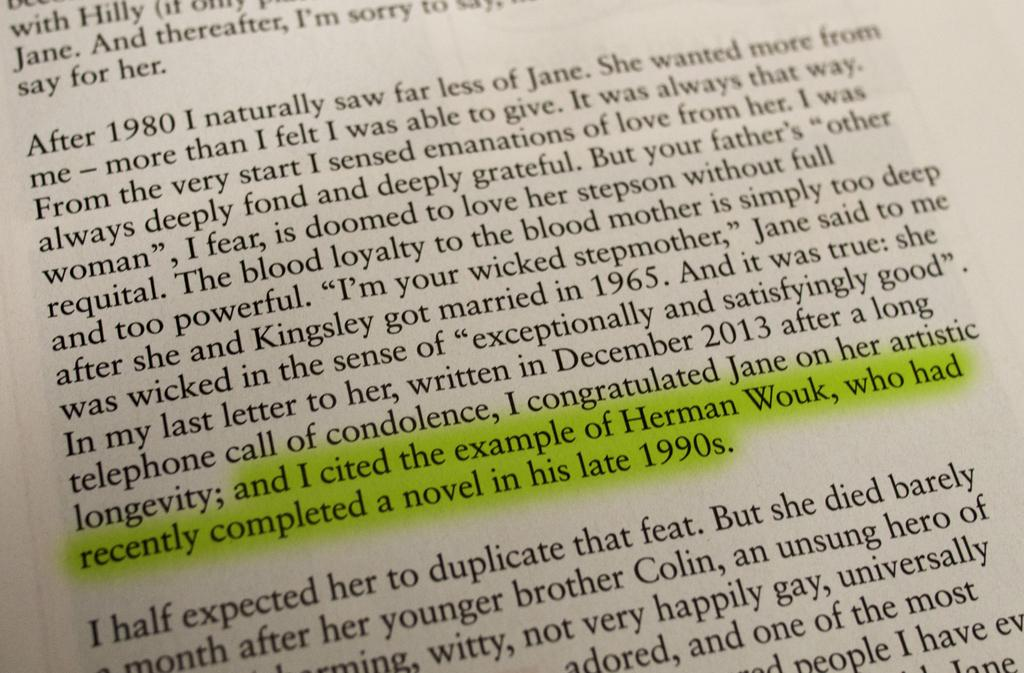<image>
Present a compact description of the photo's key features. A highlighted block of text in a book references the author Herman Wouk. 